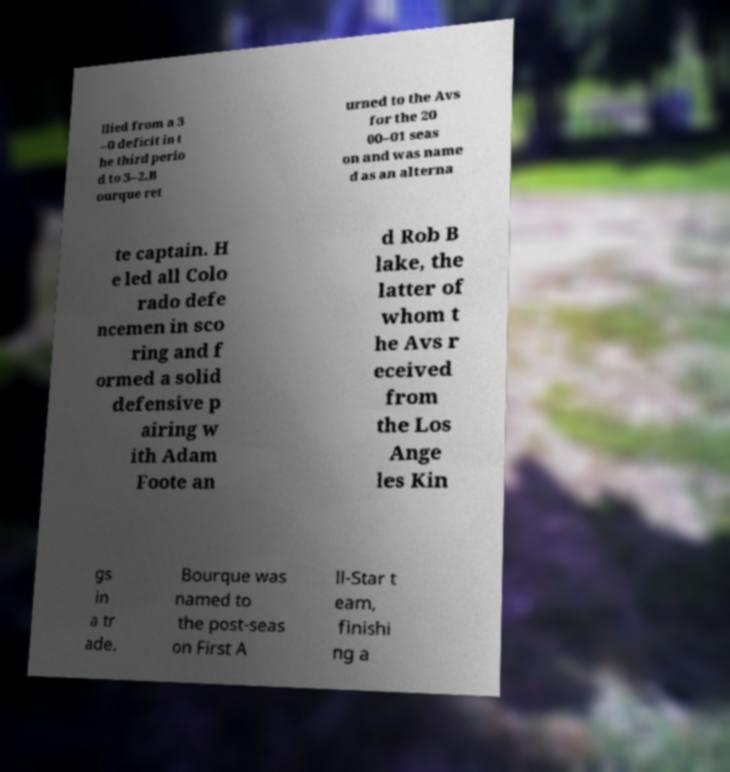Could you assist in decoding the text presented in this image and type it out clearly? llied from a 3 –0 deficit in t he third perio d to 3–2.B ourque ret urned to the Avs for the 20 00–01 seas on and was name d as an alterna te captain. H e led all Colo rado defe ncemen in sco ring and f ormed a solid defensive p airing w ith Adam Foote an d Rob B lake, the latter of whom t he Avs r eceived from the Los Ange les Kin gs in a tr ade. Bourque was named to the post-seas on First A ll-Star t eam, finishi ng a 